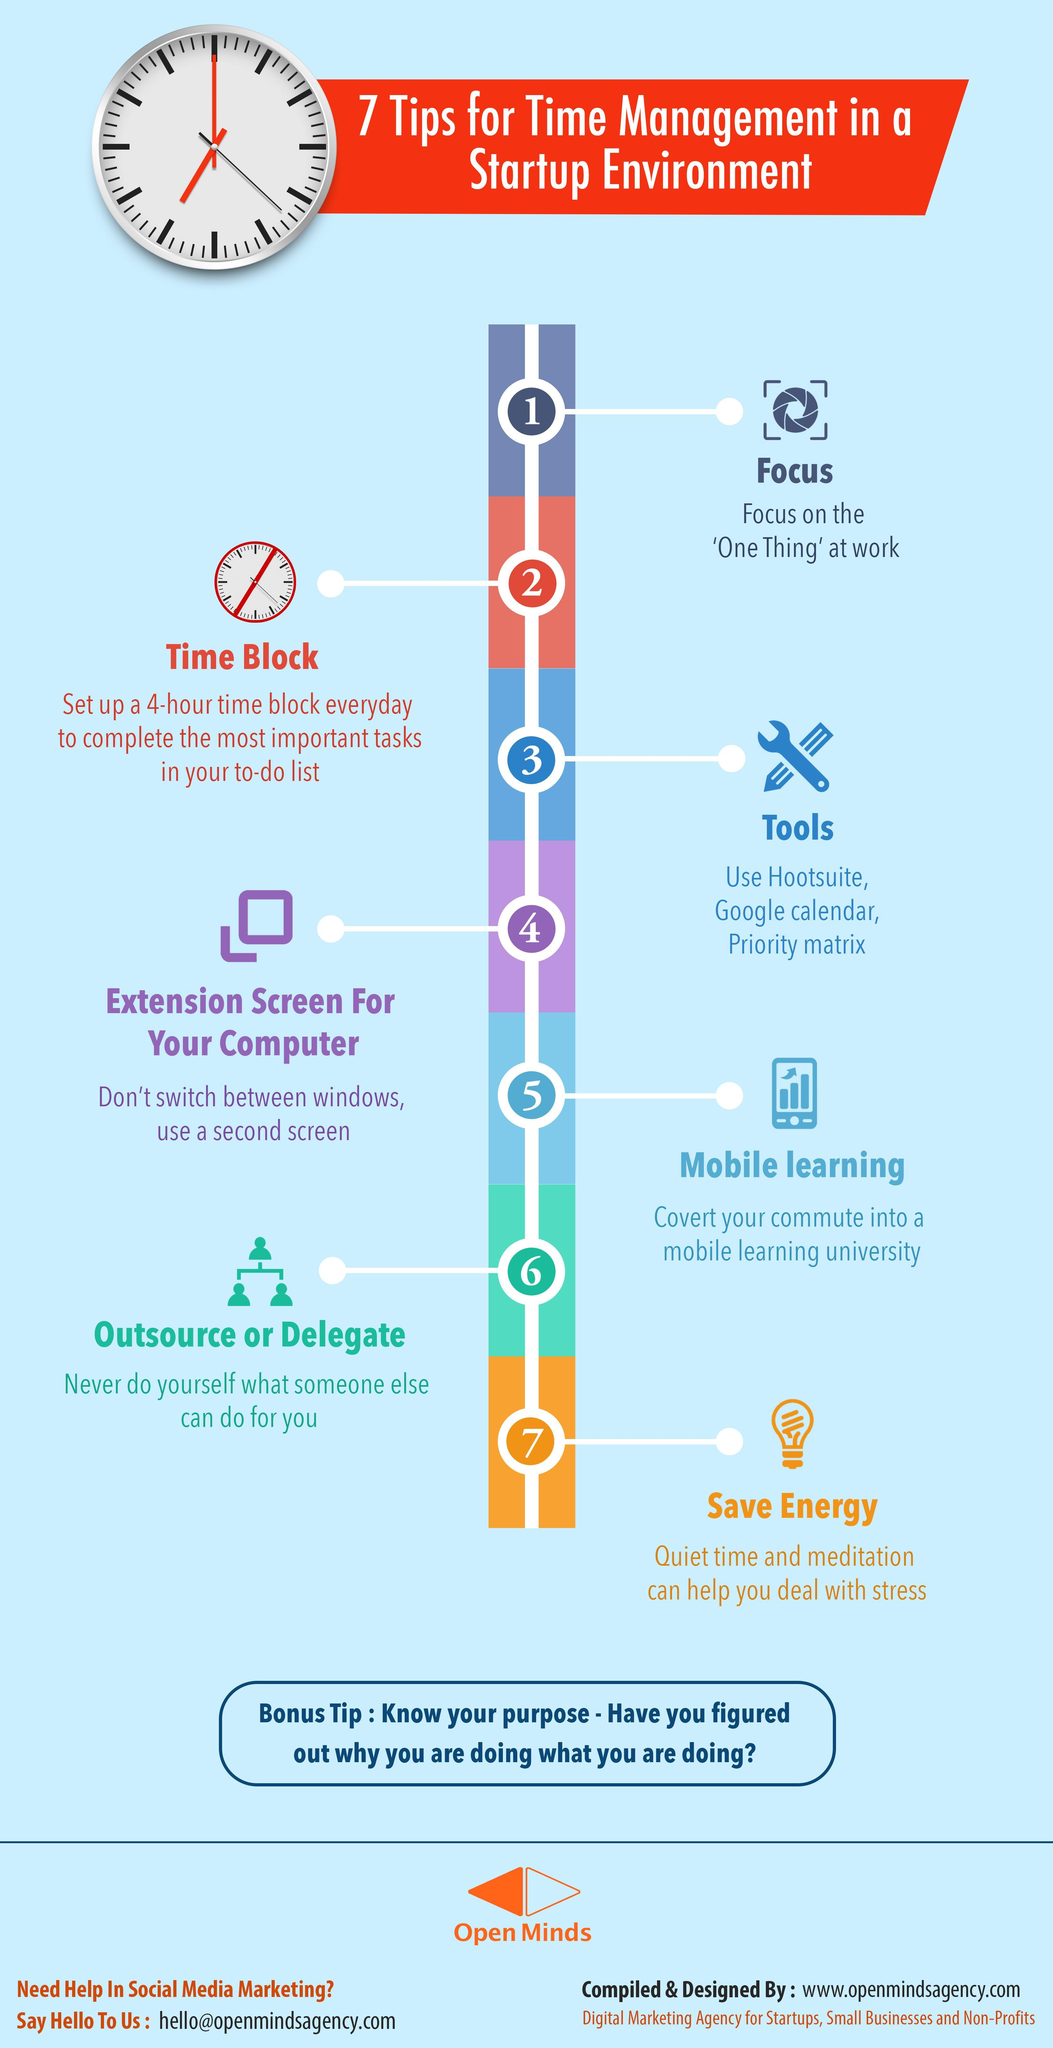What is the tip number corresponding to the tip suggesting use of a second screen?
Answer the question with a short phrase. 4 What comes third in the list of tools that help in time management? Priority matrix Which tip says about studying while travelling? Mobile learning What comes second in the list of tools that help in time management? Google Calendar In which tip number is it suggested to complete the tasks in your to-do list? 2 Which is the last tip written on the left side of the image? Outsource or delegate How many tips are mentioned on the right hand side of the image? 4 How many tips are mentioned on the left hand side of the image? 3 